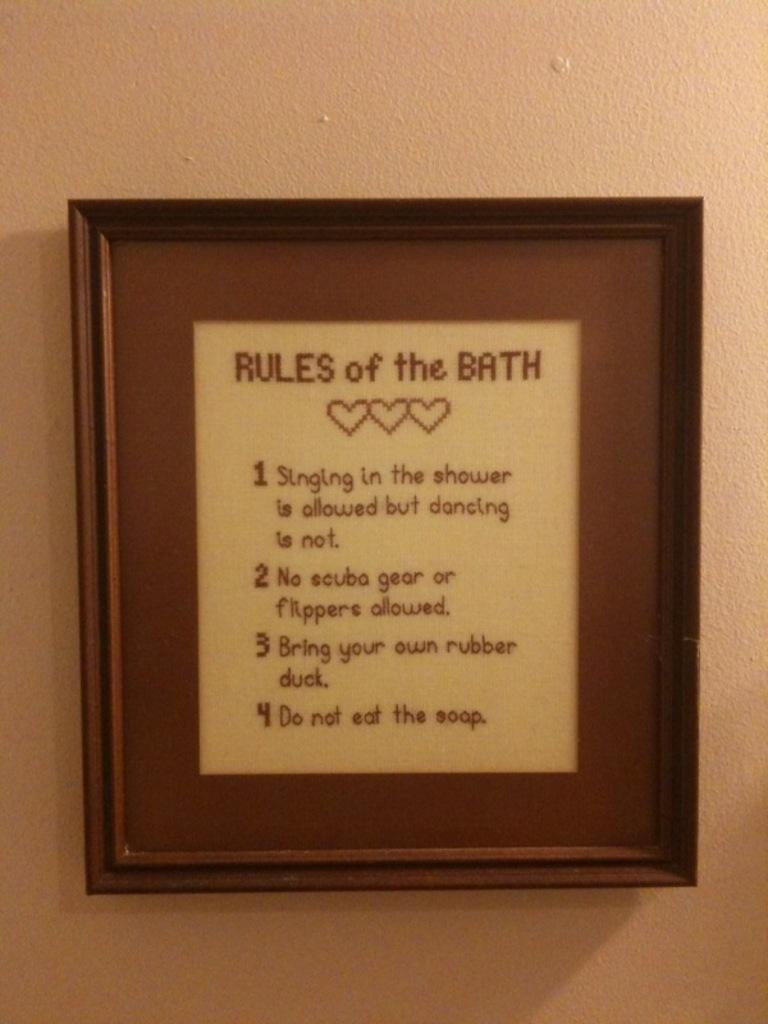<image>
Offer a succinct explanation of the picture presented. Framed saying hanging on the wall that says Rules of the Bath. 